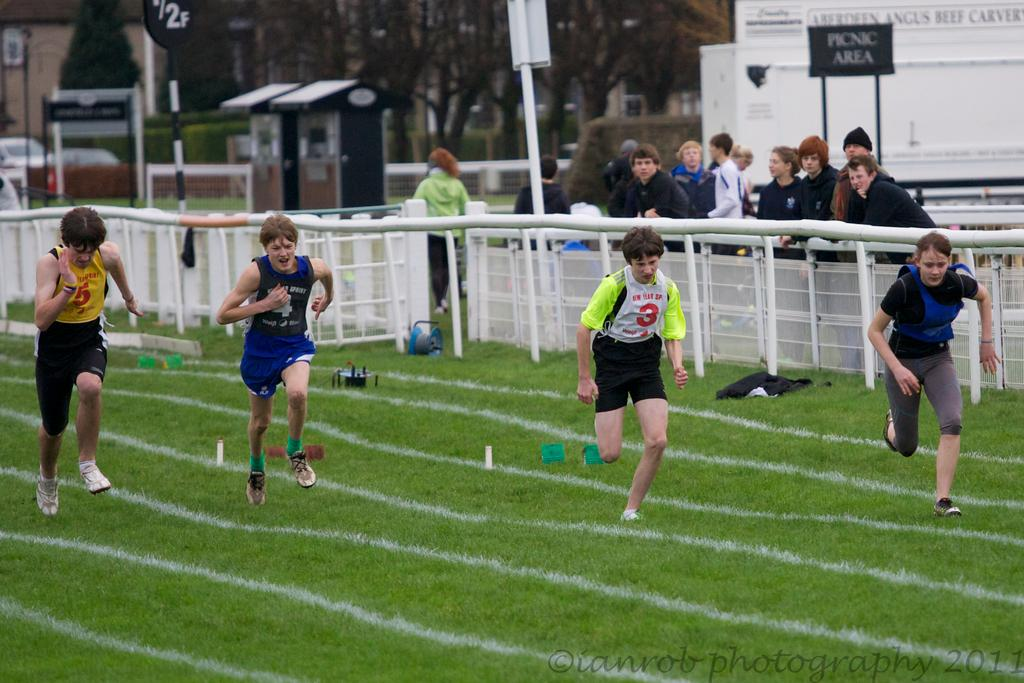How many people are present in the image? There are four people in the image. What are the people doing in the image? The people are running on the ground. What can be seen in the background of the image? There is a fence, trees, and poles in the background of the image. What type of property is being discussed by the people in the image? There is no discussion of property in the image; the people are running on the ground. What kind of breakfast is being served to the people in the image? There is no breakfast present in the image; the people are running on the ground. 